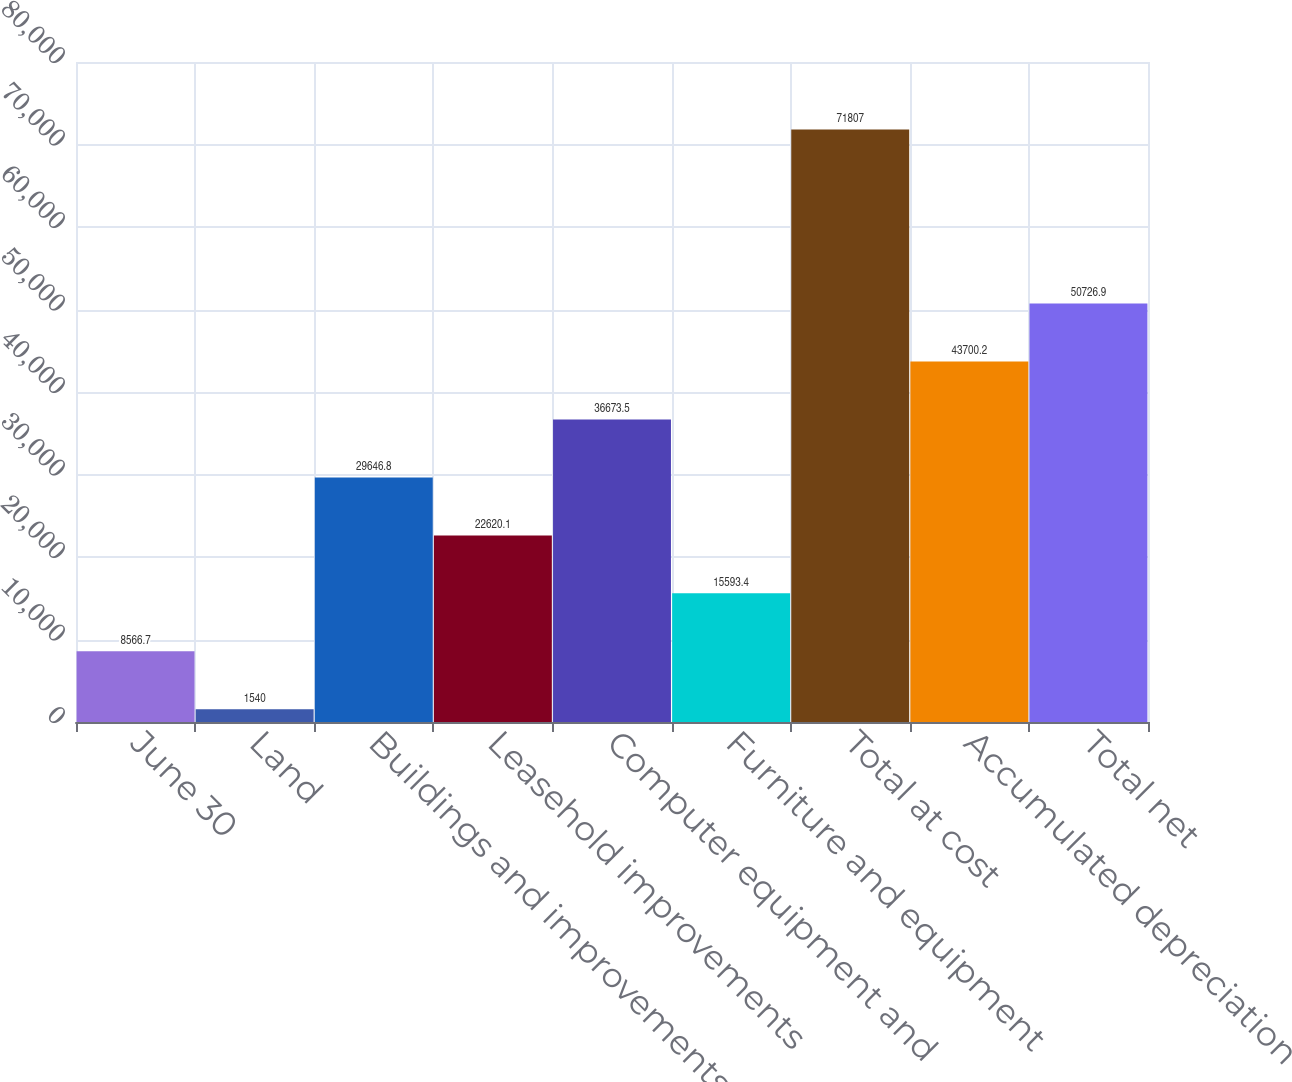Convert chart. <chart><loc_0><loc_0><loc_500><loc_500><bar_chart><fcel>June 30<fcel>Land<fcel>Buildings and improvements<fcel>Leasehold improvements<fcel>Computer equipment and<fcel>Furniture and equipment<fcel>Total at cost<fcel>Accumulated depreciation<fcel>Total net<nl><fcel>8566.7<fcel>1540<fcel>29646.8<fcel>22620.1<fcel>36673.5<fcel>15593.4<fcel>71807<fcel>43700.2<fcel>50726.9<nl></chart> 